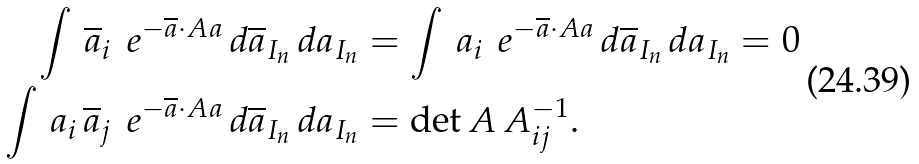<formula> <loc_0><loc_0><loc_500><loc_500>\int \, \overline { a } _ { i } \, \ e ^ { - \overline { a } \cdot A a } \, d \overline { a } _ { I _ { n } } \, d a _ { I _ { n } } & = \int \, a _ { i } \, \ e ^ { - \overline { a } \cdot A a } \, d \overline { a } _ { I _ { n } } \, d a _ { I _ { n } } = 0 \\ \int \, a _ { i } \, \overline { a } _ { j } \, \ e ^ { - \overline { a } \cdot A a } \, d \overline { a } _ { I _ { n } } \, d a _ { I _ { n } } & = \det A \, A ^ { - 1 } _ { i j } .</formula> 